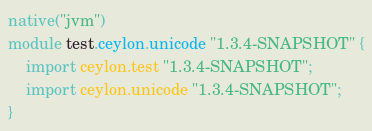Convert code to text. <code><loc_0><loc_0><loc_500><loc_500><_Ceylon_>native("jvm")
module test.ceylon.unicode "1.3.4-SNAPSHOT" {
    import ceylon.test "1.3.4-SNAPSHOT";
    import ceylon.unicode "1.3.4-SNAPSHOT";
}
</code> 